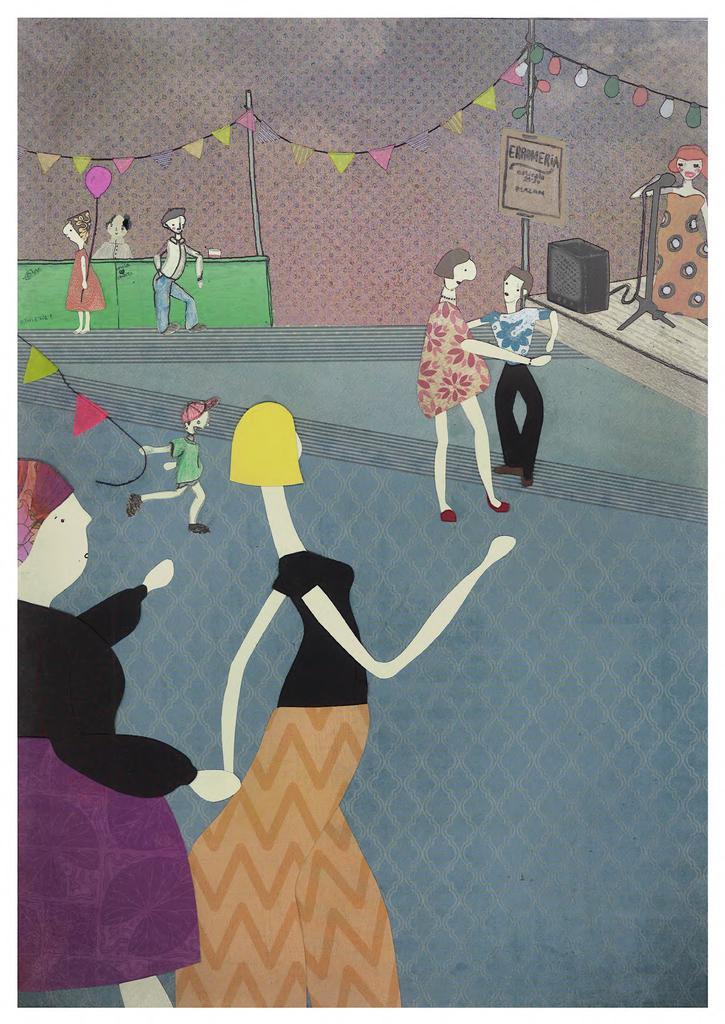Can you describe this image briefly? Here this image looks like a cartoon image, in which we can see people walking, dancing and standing and we an see a speaker and a microphone and a board over there and we can see decoration all over the place. 